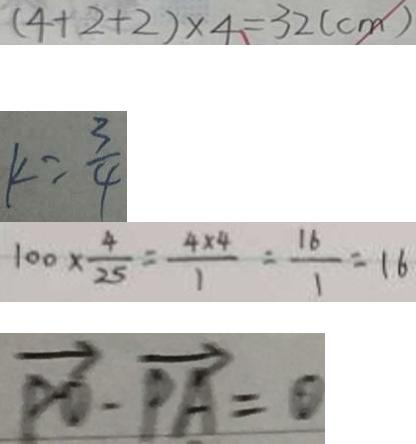Convert formula to latex. <formula><loc_0><loc_0><loc_500><loc_500>( 4 + 2 + 2 ) \times 4 = 3 2 ( c m ) 
 k = \frac { 3 } { 4 } 
 1 0 0 \times \frac { 4 } { 2 5 } = \frac { 4 \times 4 } { 1 } = \frac { 1 6 } { 1 } = 1 6 
 \overrightarrow { P O } - \overrightarrow { P A } = \theta</formula> 